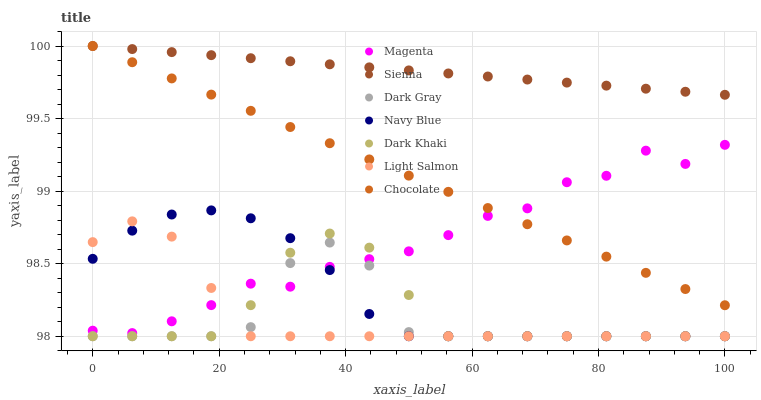Does Dark Gray have the minimum area under the curve?
Answer yes or no. Yes. Does Sienna have the maximum area under the curve?
Answer yes or no. Yes. Does Light Salmon have the minimum area under the curve?
Answer yes or no. No. Does Light Salmon have the maximum area under the curve?
Answer yes or no. No. Is Chocolate the smoothest?
Answer yes or no. Yes. Is Dark Gray the roughest?
Answer yes or no. Yes. Is Light Salmon the smoothest?
Answer yes or no. No. Is Light Salmon the roughest?
Answer yes or no. No. Does Dark Gray have the lowest value?
Answer yes or no. Yes. Does Chocolate have the lowest value?
Answer yes or no. No. Does Sienna have the highest value?
Answer yes or no. Yes. Does Light Salmon have the highest value?
Answer yes or no. No. Is Navy Blue less than Chocolate?
Answer yes or no. Yes. Is Chocolate greater than Navy Blue?
Answer yes or no. Yes. Does Navy Blue intersect Magenta?
Answer yes or no. Yes. Is Navy Blue less than Magenta?
Answer yes or no. No. Is Navy Blue greater than Magenta?
Answer yes or no. No. Does Navy Blue intersect Chocolate?
Answer yes or no. No. 